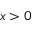Convert formula to latex. <formula><loc_0><loc_0><loc_500><loc_500>x > 0</formula> 